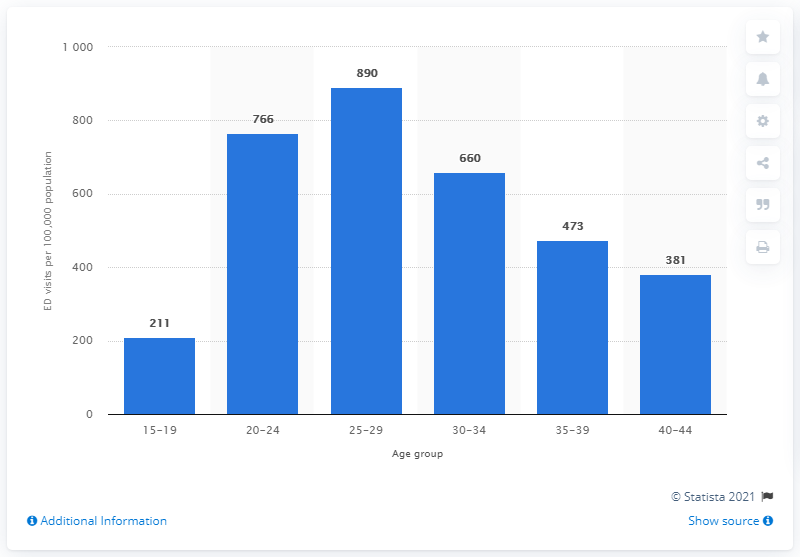Point out several critical features in this image. In 2009, there were approximately 890 dental-related emergency department visits per 100,000 Americans. 